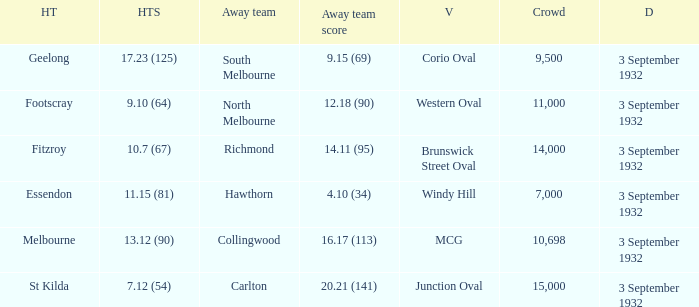What is the name of the Venue for the team that has an Away team score of 14.11 (95)? Brunswick Street Oval. Help me parse the entirety of this table. {'header': ['HT', 'HTS', 'Away team', 'Away team score', 'V', 'Crowd', 'D'], 'rows': [['Geelong', '17.23 (125)', 'South Melbourne', '9.15 (69)', 'Corio Oval', '9,500', '3 September 1932'], ['Footscray', '9.10 (64)', 'North Melbourne', '12.18 (90)', 'Western Oval', '11,000', '3 September 1932'], ['Fitzroy', '10.7 (67)', 'Richmond', '14.11 (95)', 'Brunswick Street Oval', '14,000', '3 September 1932'], ['Essendon', '11.15 (81)', 'Hawthorn', '4.10 (34)', 'Windy Hill', '7,000', '3 September 1932'], ['Melbourne', '13.12 (90)', 'Collingwood', '16.17 (113)', 'MCG', '10,698', '3 September 1932'], ['St Kilda', '7.12 (54)', 'Carlton', '20.21 (141)', 'Junction Oval', '15,000', '3 September 1932']]} 